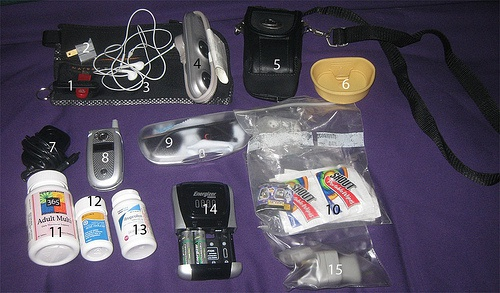Describe the objects in this image and their specific colors. I can see a cell phone in black, gray, darkgray, and white tones in this image. 